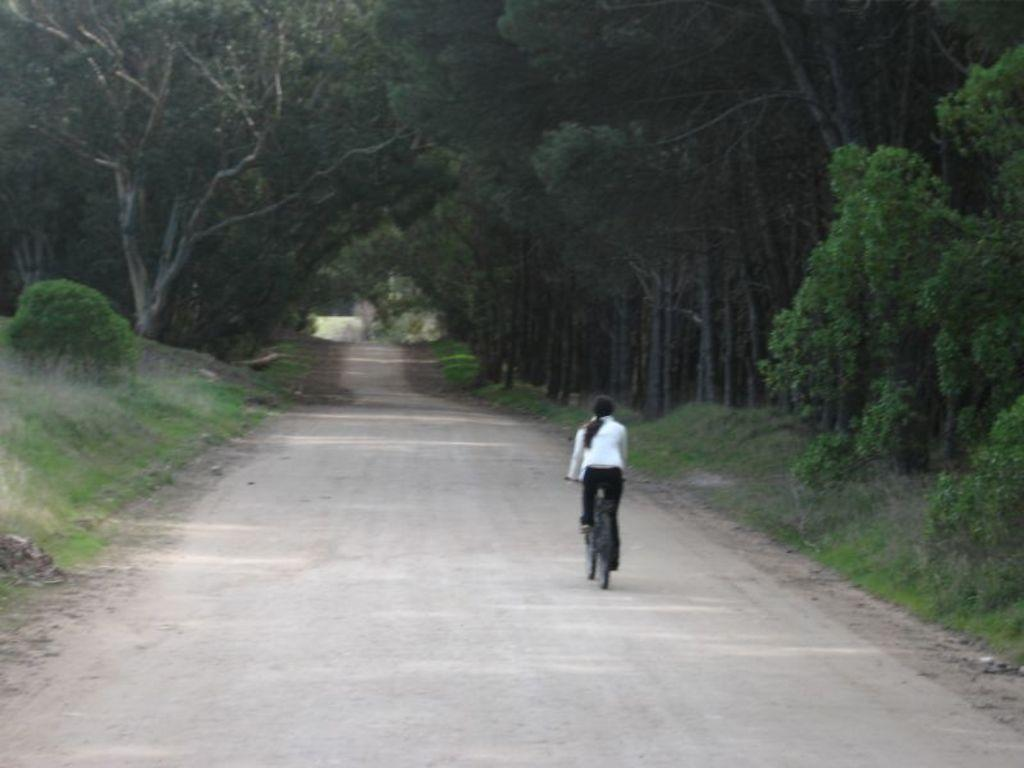Who is the main subject in the image? There is a woman in the image. What is the woman doing in the image? The woman is riding a bicycle. Where is the bicycle located? The bicycle is on a road. What can be seen on either side of the road? There are plants on either side of the road. What type of vegetation is present in the area? There are trees present all over the area. Can you tell me how many bears are visible in the image? There are no bears present in the image. What type of grass is the queen sitting on in the image? There is no queen or grass present in the image. 